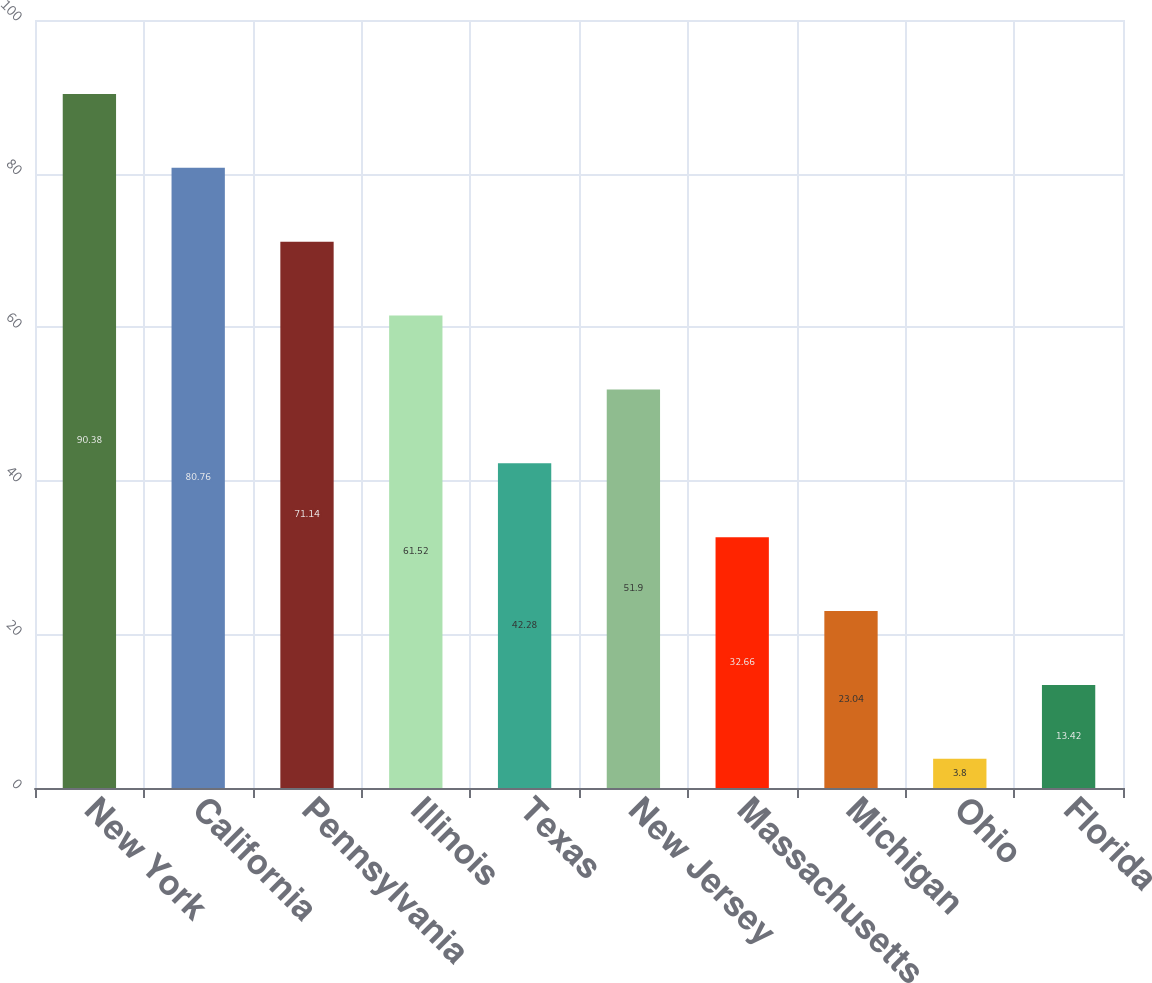Convert chart. <chart><loc_0><loc_0><loc_500><loc_500><bar_chart><fcel>New York<fcel>California<fcel>Pennsylvania<fcel>Illinois<fcel>Texas<fcel>New Jersey<fcel>Massachusetts<fcel>Michigan<fcel>Ohio<fcel>Florida<nl><fcel>90.38<fcel>80.76<fcel>71.14<fcel>61.52<fcel>42.28<fcel>51.9<fcel>32.66<fcel>23.04<fcel>3.8<fcel>13.42<nl></chart> 